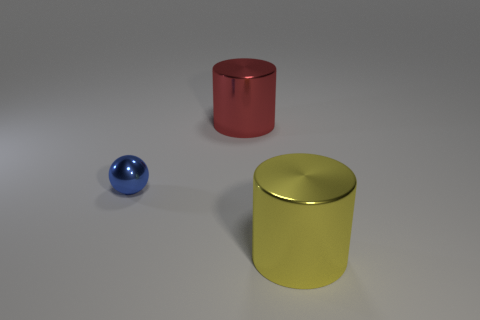Does the shiny cylinder in front of the red cylinder have the same size as the blue shiny sphere behind the big yellow metal object?
Keep it short and to the point. No. What size is the cylinder that is made of the same material as the big yellow thing?
Your answer should be very brief. Large. What number of metal things are both to the left of the yellow shiny cylinder and on the right side of the blue thing?
Offer a terse response. 1. What number of objects are either green metal cubes or shiny objects behind the blue thing?
Give a very brief answer. 1. There is a big cylinder in front of the tiny ball; what is its color?
Keep it short and to the point. Yellow. How many things are either large things that are to the right of the red thing or tiny blue objects?
Offer a very short reply. 2. There is another object that is the same size as the yellow metallic thing; what color is it?
Keep it short and to the point. Red. Is the number of tiny blue metal things that are behind the yellow metallic object greater than the number of tiny red cubes?
Ensure brevity in your answer.  Yes. What number of other objects are there of the same size as the yellow thing?
Give a very brief answer. 1. Are there any tiny balls behind the large metal object to the left of the large thing in front of the blue metal ball?
Make the answer very short. No. 